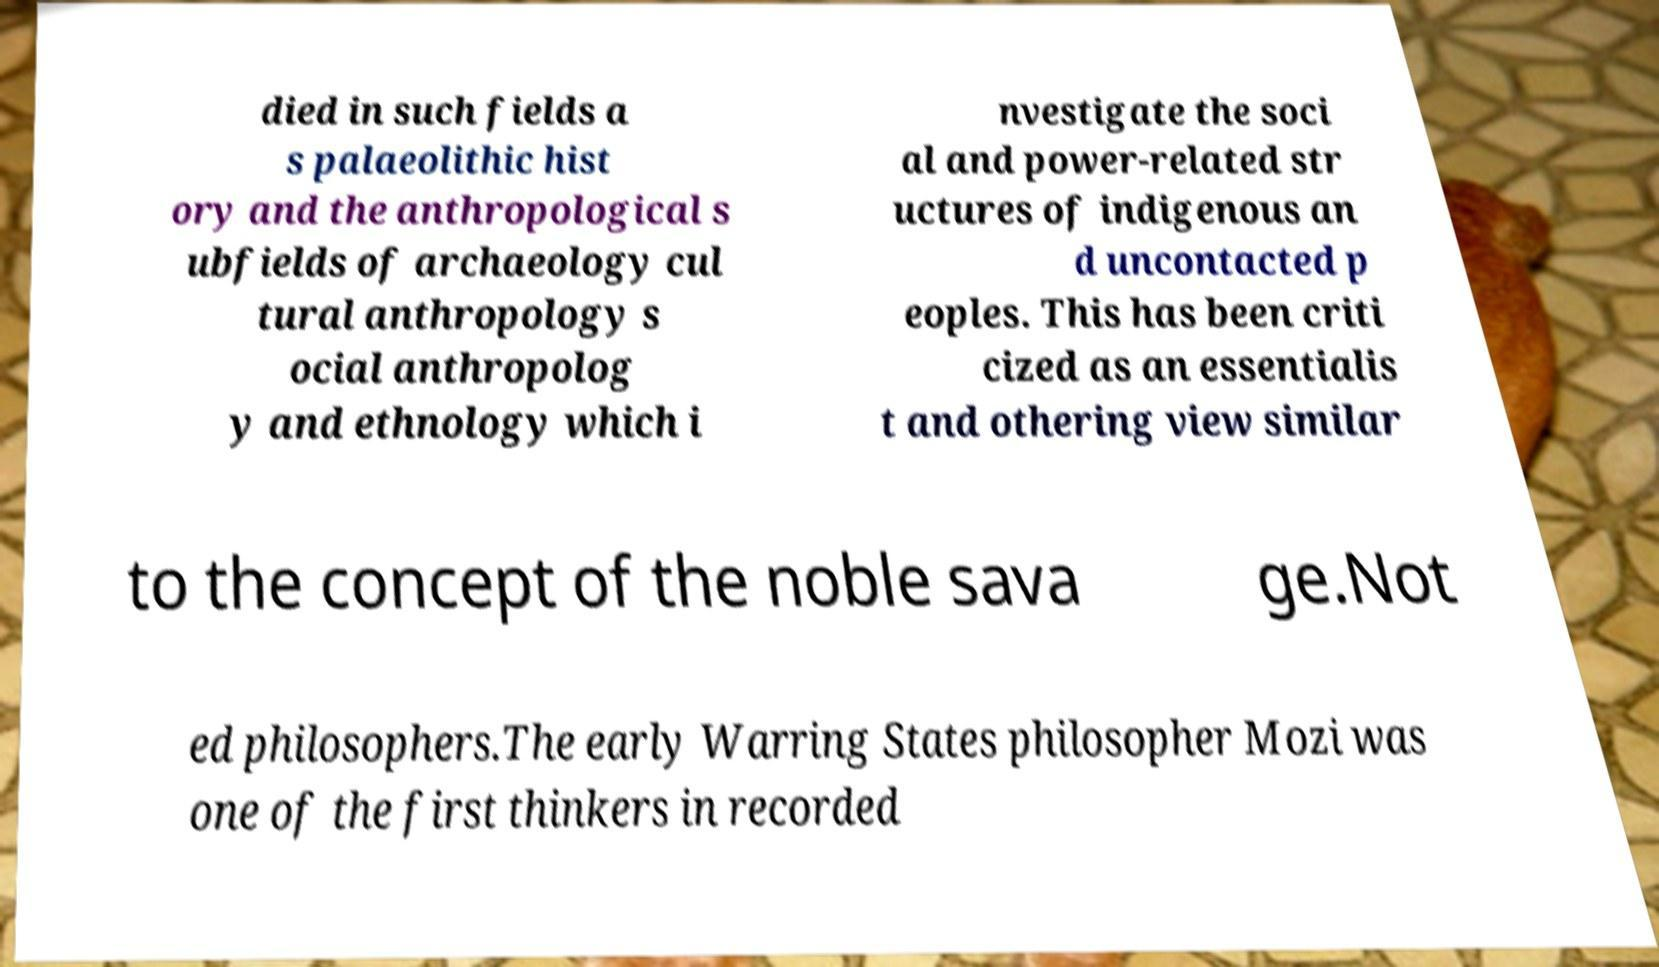There's text embedded in this image that I need extracted. Can you transcribe it verbatim? died in such fields a s palaeolithic hist ory and the anthropological s ubfields of archaeology cul tural anthropology s ocial anthropolog y and ethnology which i nvestigate the soci al and power-related str uctures of indigenous an d uncontacted p eoples. This has been criti cized as an essentialis t and othering view similar to the concept of the noble sava ge.Not ed philosophers.The early Warring States philosopher Mozi was one of the first thinkers in recorded 